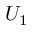Convert formula to latex. <formula><loc_0><loc_0><loc_500><loc_500>U _ { 1 }</formula> 